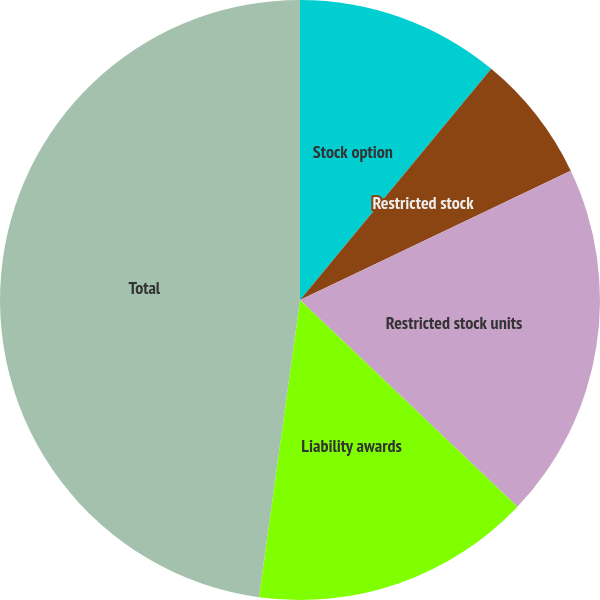Convert chart to OTSL. <chart><loc_0><loc_0><loc_500><loc_500><pie_chart><fcel>Stock option<fcel>Restricted stock<fcel>Restricted stock units<fcel>Liability awards<fcel>Total<nl><fcel>11.0%<fcel>6.91%<fcel>19.18%<fcel>15.09%<fcel>47.81%<nl></chart> 